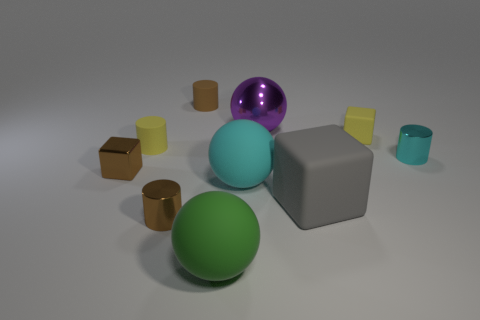How many other objects are there of the same material as the big cyan sphere?
Provide a short and direct response. 5. There is a purple ball that is the same size as the gray matte object; what is its material?
Offer a very short reply. Metal. Is the shape of the large object that is behind the cyan ball the same as the yellow thing on the left side of the large purple metal sphere?
Your response must be concise. No. What shape is the green rubber thing that is the same size as the gray block?
Offer a terse response. Sphere. Do the cylinder in front of the tiny brown metallic cube and the tiny yellow object to the left of the large shiny sphere have the same material?
Your answer should be very brief. No. There is a tiny metallic cylinder that is in front of the cyan shiny cylinder; are there any tiny cyan metal cylinders that are right of it?
Your answer should be very brief. Yes. The big ball that is the same material as the tiny brown block is what color?
Ensure brevity in your answer.  Purple. Is the number of brown rubber objects greater than the number of tiny metal cylinders?
Your response must be concise. No. How many objects are either big cyan spheres that are in front of the cyan metallic cylinder or yellow shiny objects?
Provide a short and direct response. 1. Are there any cyan rubber objects that have the same size as the brown matte cylinder?
Your answer should be compact. No. 